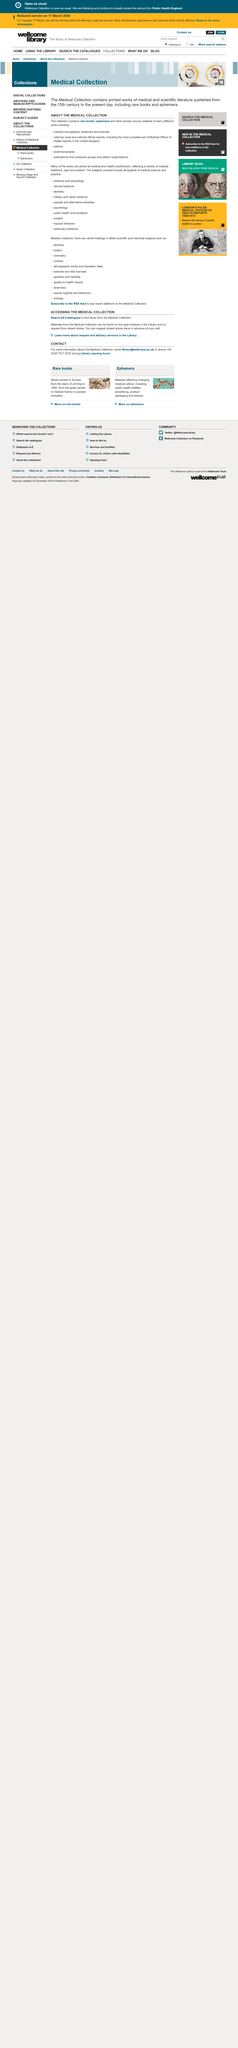Highlight a few significant elements in this photo. A public health leaflet is an example of ephemera, not a rare book. An advertisement is not an example of a rare book, but rather an example of ephemera. A stamp is an example of ephemera, which is defined as transient or fleeting items that are not intended to be long-lasting or preserved. 